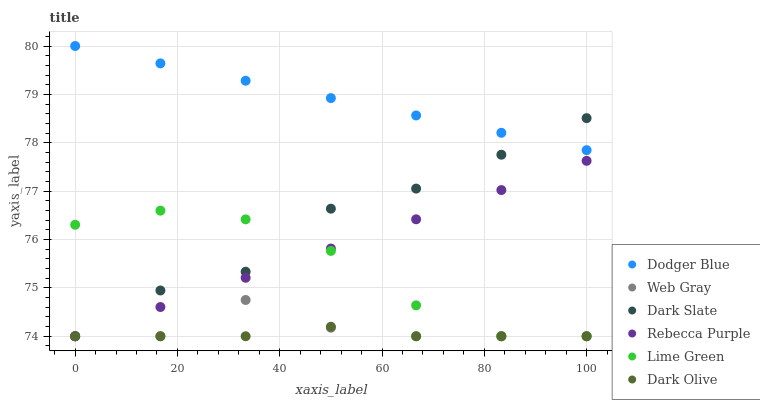Does Dark Olive have the minimum area under the curve?
Answer yes or no. Yes. Does Dodger Blue have the maximum area under the curve?
Answer yes or no. Yes. Does Dark Slate have the minimum area under the curve?
Answer yes or no. No. Does Dark Slate have the maximum area under the curve?
Answer yes or no. No. Is Rebecca Purple the smoothest?
Answer yes or no. Yes. Is Dark Slate the roughest?
Answer yes or no. Yes. Is Dark Olive the smoothest?
Answer yes or no. No. Is Dark Olive the roughest?
Answer yes or no. No. Does Web Gray have the lowest value?
Answer yes or no. Yes. Does Dodger Blue have the lowest value?
Answer yes or no. No. Does Dodger Blue have the highest value?
Answer yes or no. Yes. Does Dark Slate have the highest value?
Answer yes or no. No. Is Lime Green less than Dodger Blue?
Answer yes or no. Yes. Is Dodger Blue greater than Dark Olive?
Answer yes or no. Yes. Does Rebecca Purple intersect Dark Slate?
Answer yes or no. Yes. Is Rebecca Purple less than Dark Slate?
Answer yes or no. No. Is Rebecca Purple greater than Dark Slate?
Answer yes or no. No. Does Lime Green intersect Dodger Blue?
Answer yes or no. No. 